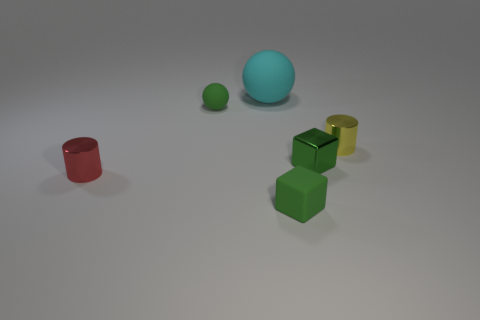Is the number of red cylinders that are behind the yellow metallic cylinder less than the number of tiny cylinders that are behind the small shiny block?
Your answer should be compact. Yes. What number of other things are there of the same material as the small yellow cylinder
Offer a very short reply. 2. There is a sphere that is the same size as the red thing; what material is it?
Your response must be concise. Rubber. Are there fewer red shiny cylinders right of the small green metal object than green matte things?
Give a very brief answer. Yes. There is a tiny metallic object behind the block that is behind the matte object in front of the red cylinder; what is its shape?
Give a very brief answer. Cylinder. There is a metallic cylinder that is on the right side of the cyan ball; how big is it?
Provide a short and direct response. Small. The yellow thing that is the same size as the red thing is what shape?
Offer a terse response. Cylinder. How many things are cyan rubber balls or tiny metallic cylinders in front of the small green shiny cube?
Offer a terse response. 2. How many tiny green matte cubes are left of the large object that is on the left side of the green rubber object in front of the tiny yellow thing?
Your answer should be very brief. 0. What is the color of the other sphere that is the same material as the small green ball?
Your response must be concise. Cyan. 